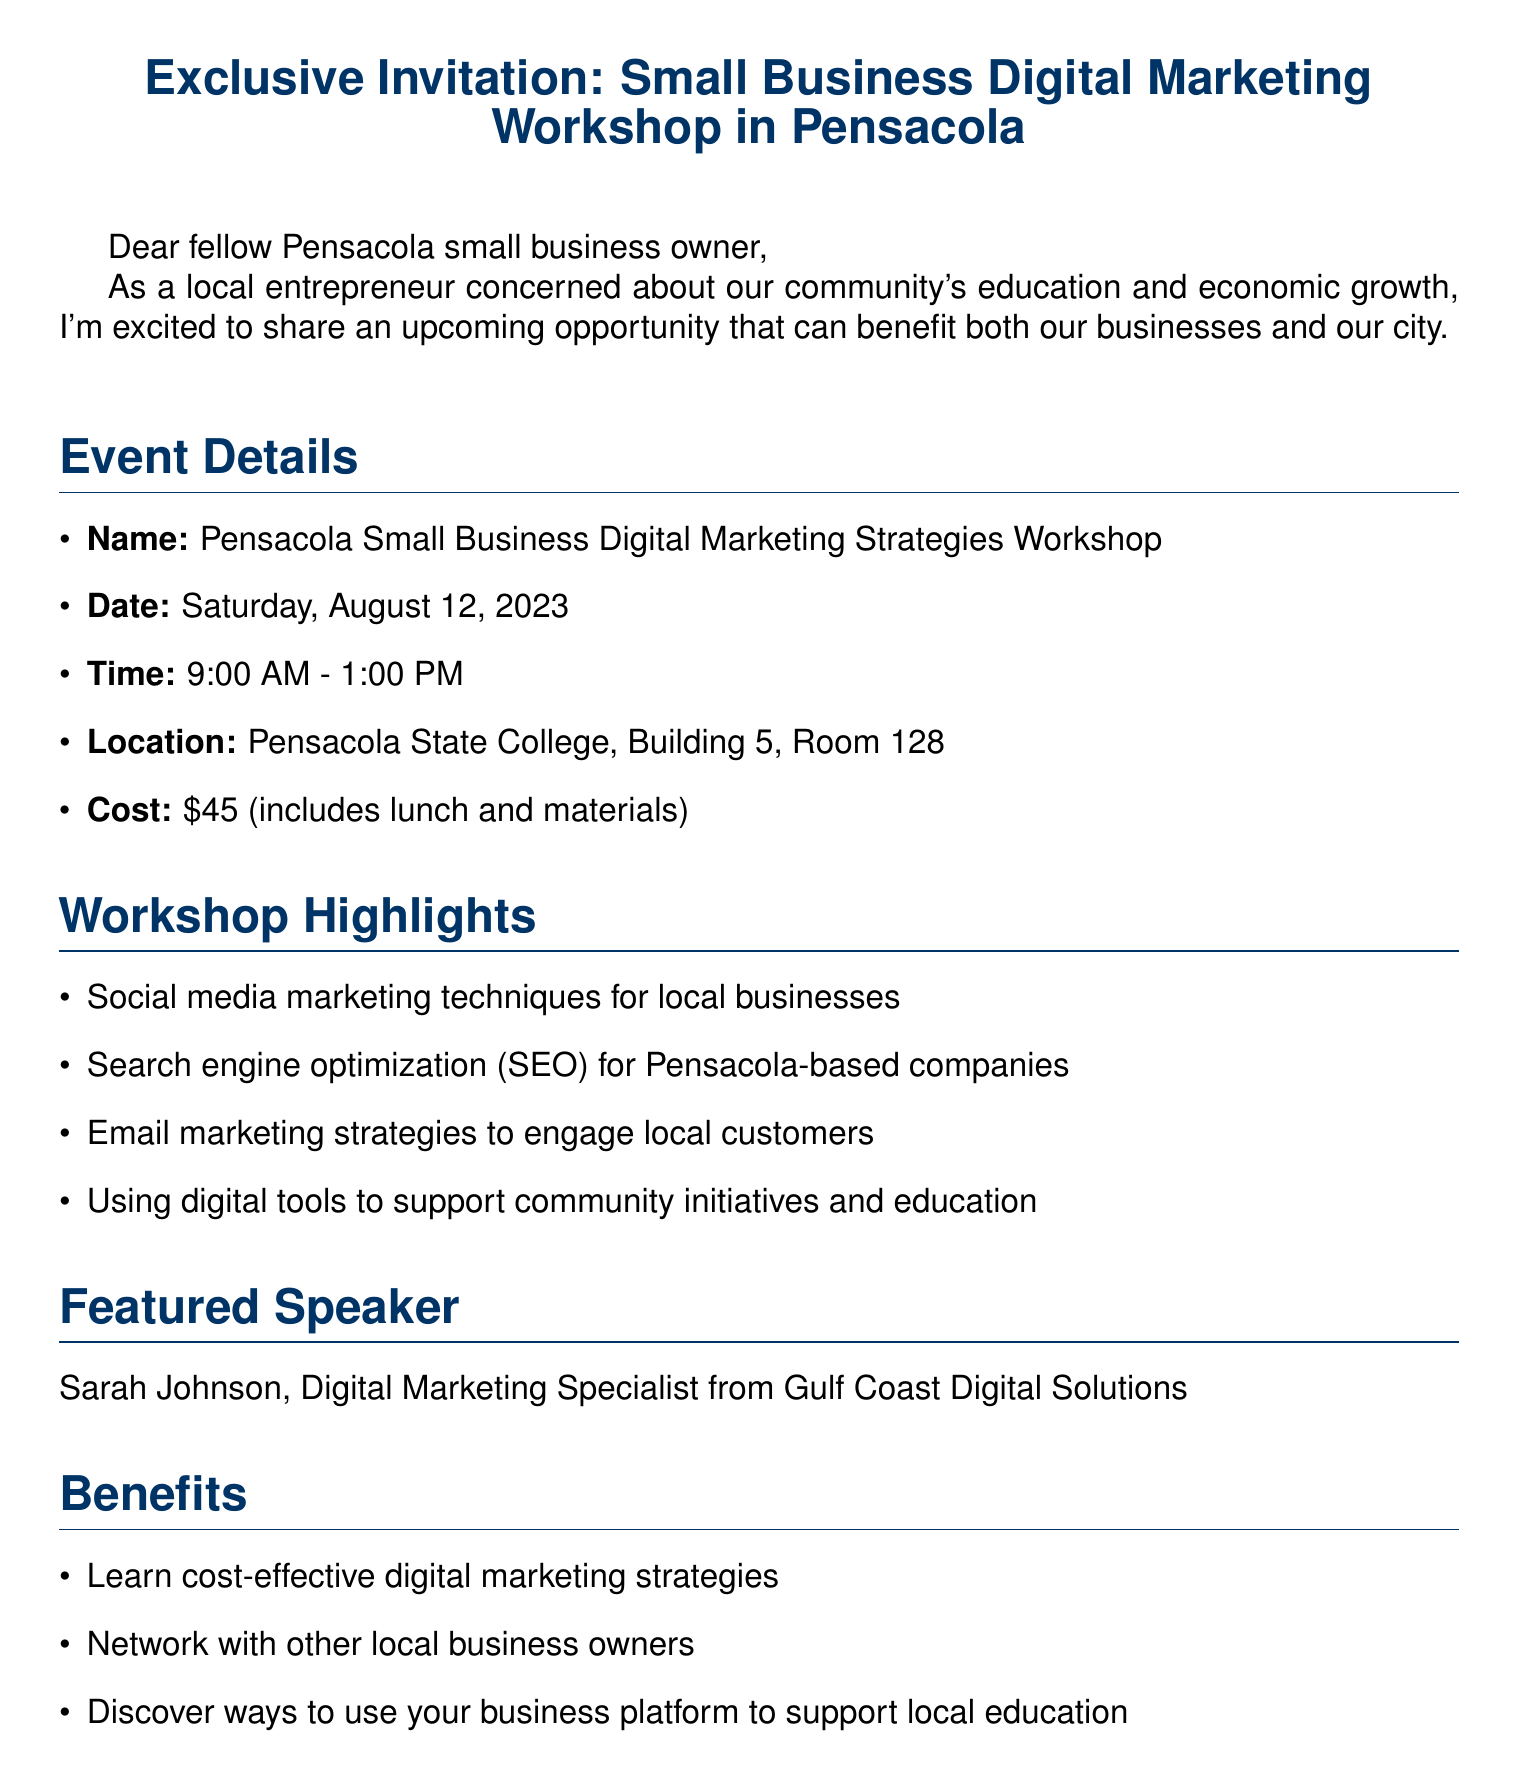What is the name of the workshop? The name of the workshop is provided in the event details section of the document.
Answer: Pensacola Small Business Digital Marketing Strategies Workshop When is the workshop scheduled to take place? The document specifies the date of the workshop in the event details section.
Answer: Saturday, August 12, 2023 What is the cost to attend the workshop? The cost of attending the workshop is mentioned in the event details section of the document.
Answer: $45 Who is the featured speaker? The document includes the name and title of the speaker in the featured speaker section.
Answer: Sarah Johnson What is one of the benefits of attending the workshop? The document lists benefits in a specific section and one of them is directly cited.
Answer: Learn cost-effective digital marketing strategies What is the registration deadline? The registration deadline is clearly stated in the registration information section of the document.
Answer: August 5, 2023 Where is the workshop being held? The location of the workshop is explicitly mentioned in the event details section of the document.
Answer: Pensacola State College, Building 5, Room 128 Who can be contacted for more information? The contact person’s name is provided in the registration information section of the document.
Answer: Mike Thompson What is the duration of the workshop? The time duration for the workshop is detailed in the event details section, indicating when it starts and ends.
Answer: 4 hours 